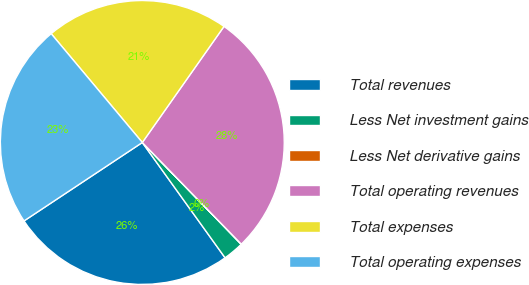Convert chart to OTSL. <chart><loc_0><loc_0><loc_500><loc_500><pie_chart><fcel>Total revenues<fcel>Less Net investment gains<fcel>Less Net derivative gains<fcel>Total operating revenues<fcel>Total expenses<fcel>Total operating expenses<nl><fcel>25.59%<fcel>2.37%<fcel>0.01%<fcel>27.95%<fcel>20.86%<fcel>23.22%<nl></chart> 